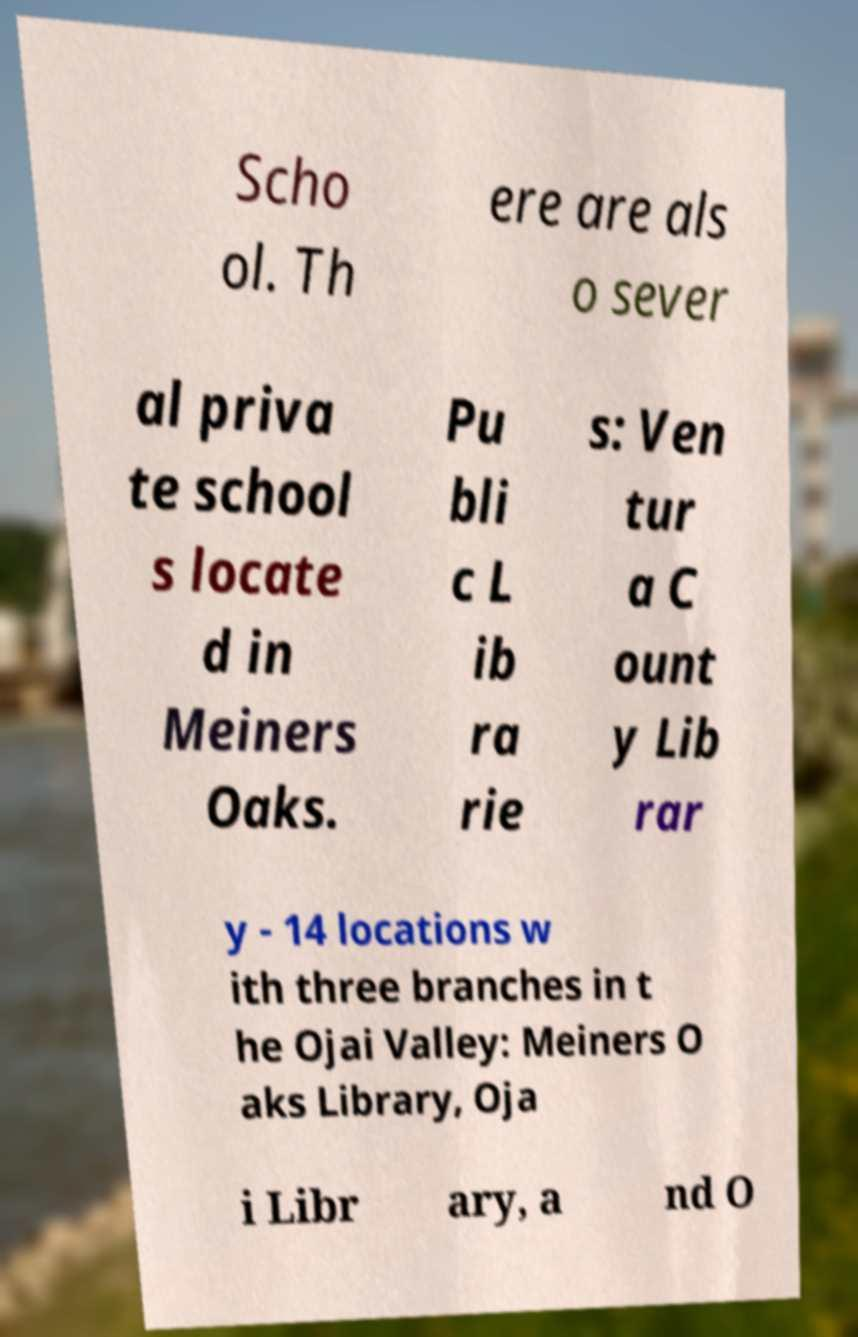There's text embedded in this image that I need extracted. Can you transcribe it verbatim? Scho ol. Th ere are als o sever al priva te school s locate d in Meiners Oaks. Pu bli c L ib ra rie s: Ven tur a C ount y Lib rar y - 14 locations w ith three branches in t he Ojai Valley: Meiners O aks Library, Oja i Libr ary, a nd O 